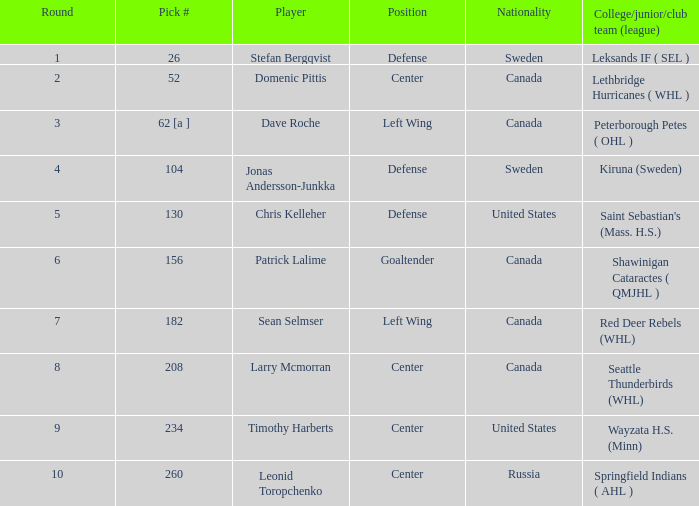In the league, which college, junior, or club team is associated with the player who was chosen as pick number 130? Saint Sebastian's (Mass. H.S.). 